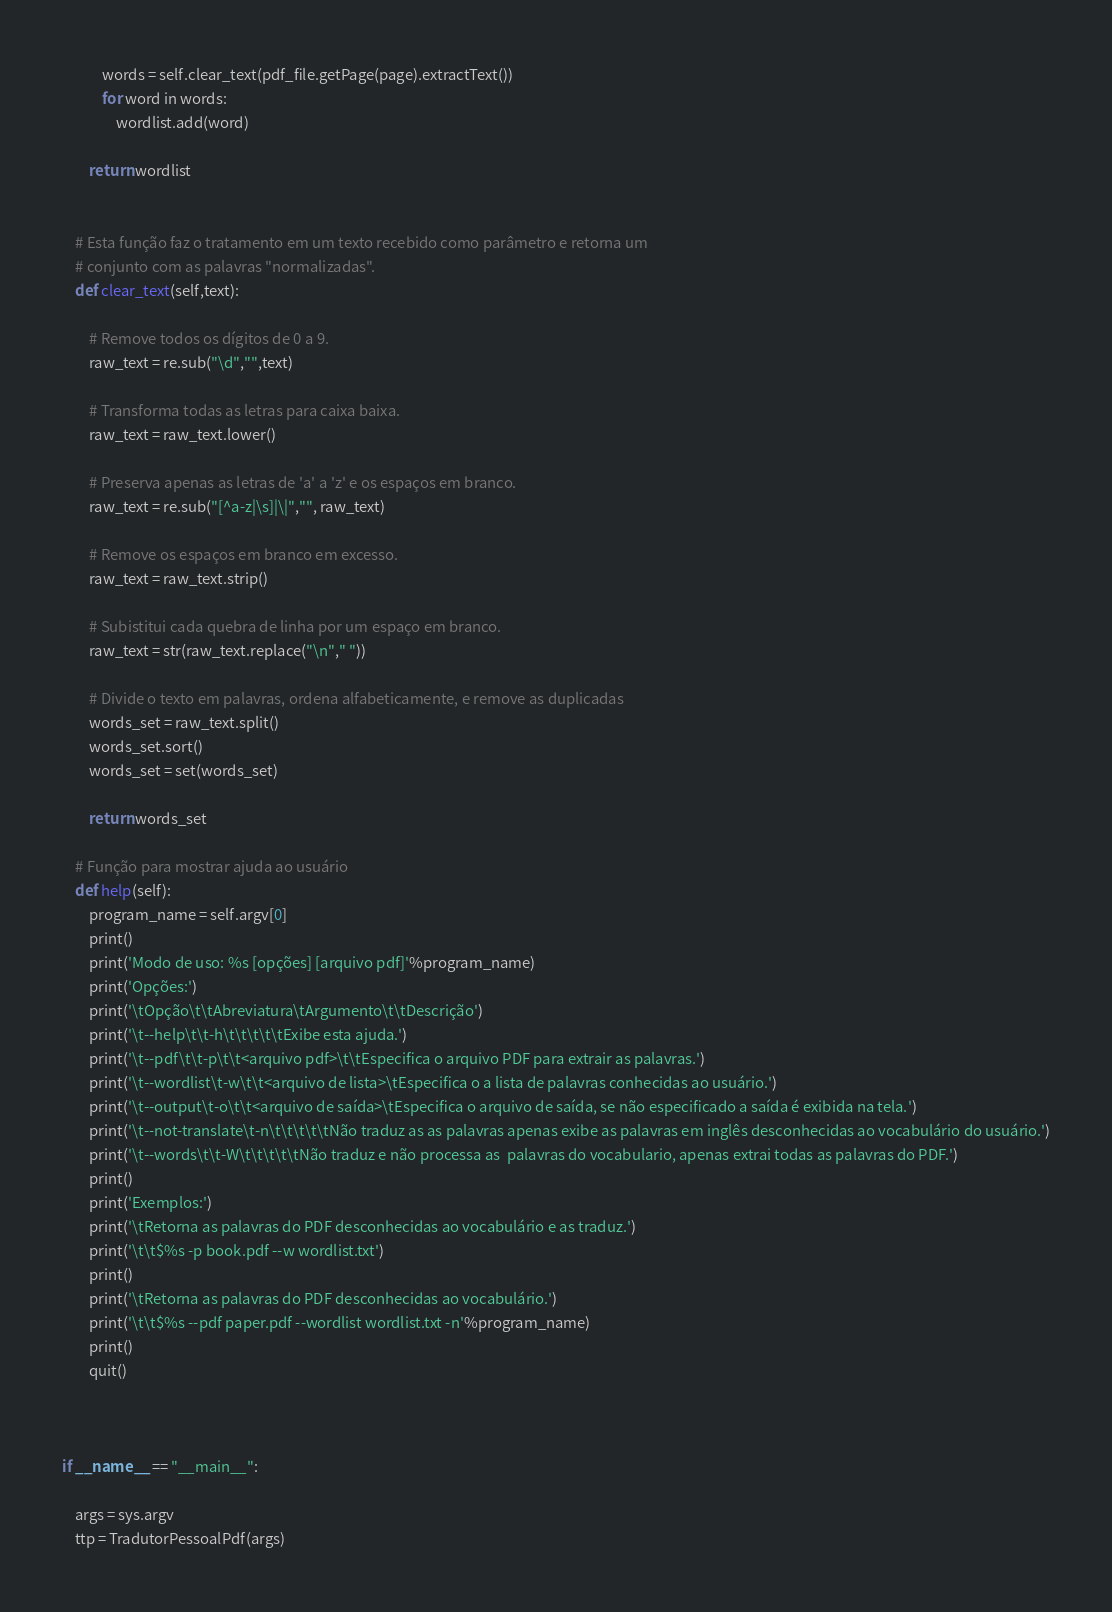<code> <loc_0><loc_0><loc_500><loc_500><_Python_>            words = self.clear_text(pdf_file.getPage(page).extractText())
            for word in words:
                wordlist.add(word)
        
        return wordlist                                                                             


    # Esta função faz o tratamento em um texto recebido como parâmetro e retorna um
    # conjunto com as palavras "normalizadas".
    def clear_text(self,text):

        # Remove todos os dígitos de 0 a 9.
        raw_text = re.sub("\d","",text)                                           

        # Transforma todas as letras para caixa baixa.
        raw_text = raw_text.lower()

        # Preserva apenas as letras de 'a' a 'z' e os espaços em branco.
        raw_text = re.sub("[^a-z|\s]|\|","", raw_text)

        # Remove os espaços em branco em excesso.
        raw_text = raw_text.strip()

        # Subistitui cada quebra de linha por um espaço em branco.
        raw_text = str(raw_text.replace("\n"," "))

        # Divide o texto em palavras, ordena alfabeticamente, e remove as duplicadas
        words_set = raw_text.split()
        words_set.sort()
        words_set = set(words_set)                                               

        return words_set                           

    # Função para mostrar ajuda ao usuário    
    def help(self):
        program_name = self.argv[0]
        print()
        print('Modo de uso: %s [opções] [arquivo pdf]'%program_name)
        print('Opções:')
        print('\tOpção\t\tAbreviatura\tArgumento\t\tDescrição')
        print('\t--help\t\t-h\t\t\t\t\tExibe esta ajuda.')
        print('\t--pdf\t\t-p\t\t<arquivo pdf>\t\tEspecifica o arquivo PDF para extrair as palavras.')
        print('\t--wordlist\t-w\t\t<arquivo de lista>\tEspecifica o a lista de palavras conhecidas ao usuário.')
        print('\t--output\t-o\t\t<arquivo de saída>\tEspecifica o arquivo de saída, se não especificado a saída é exibida na tela.')
        print('\t--not-translate\t-n\t\t\t\t\tNão traduz as as palavras apenas exibe as palavras em inglês desconhecidas ao vocabulário do usuário.')
        print('\t--words\t\t-W\t\t\t\t\tNão traduz e não processa as  palavras do vocabulario, apenas extrai todas as palavras do PDF.')
        print()
        print('Exemplos:')
        print('\tRetorna as palavras do PDF desconhecidas ao vocabulário e as traduz.')
        print('\t\t$%s -p book.pdf --w wordlist.txt')
        print()
        print('\tRetorna as palavras do PDF desconhecidas ao vocabulário.')
        print('\t\t$%s --pdf paper.pdf --wordlist wordlist.txt -n'%program_name)
        print()
        quit()



if __name__ == "__main__":

    args = sys.argv
    ttp = TradutorPessoalPdf(args)
</code> 